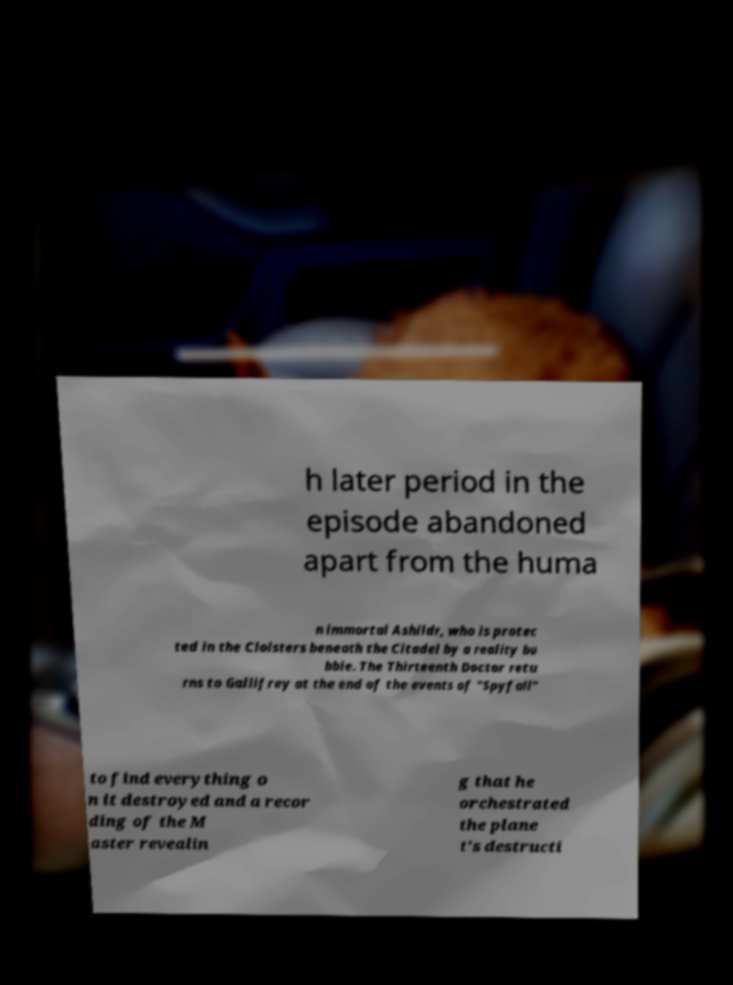Please read and relay the text visible in this image. What does it say? h later period in the episode abandoned apart from the huma n immortal Ashildr, who is protec ted in the Cloisters beneath the Citadel by a reality bu bble. The Thirteenth Doctor retu rns to Gallifrey at the end of the events of "Spyfall" to find everything o n it destroyed and a recor ding of the M aster revealin g that he orchestrated the plane t's destructi 